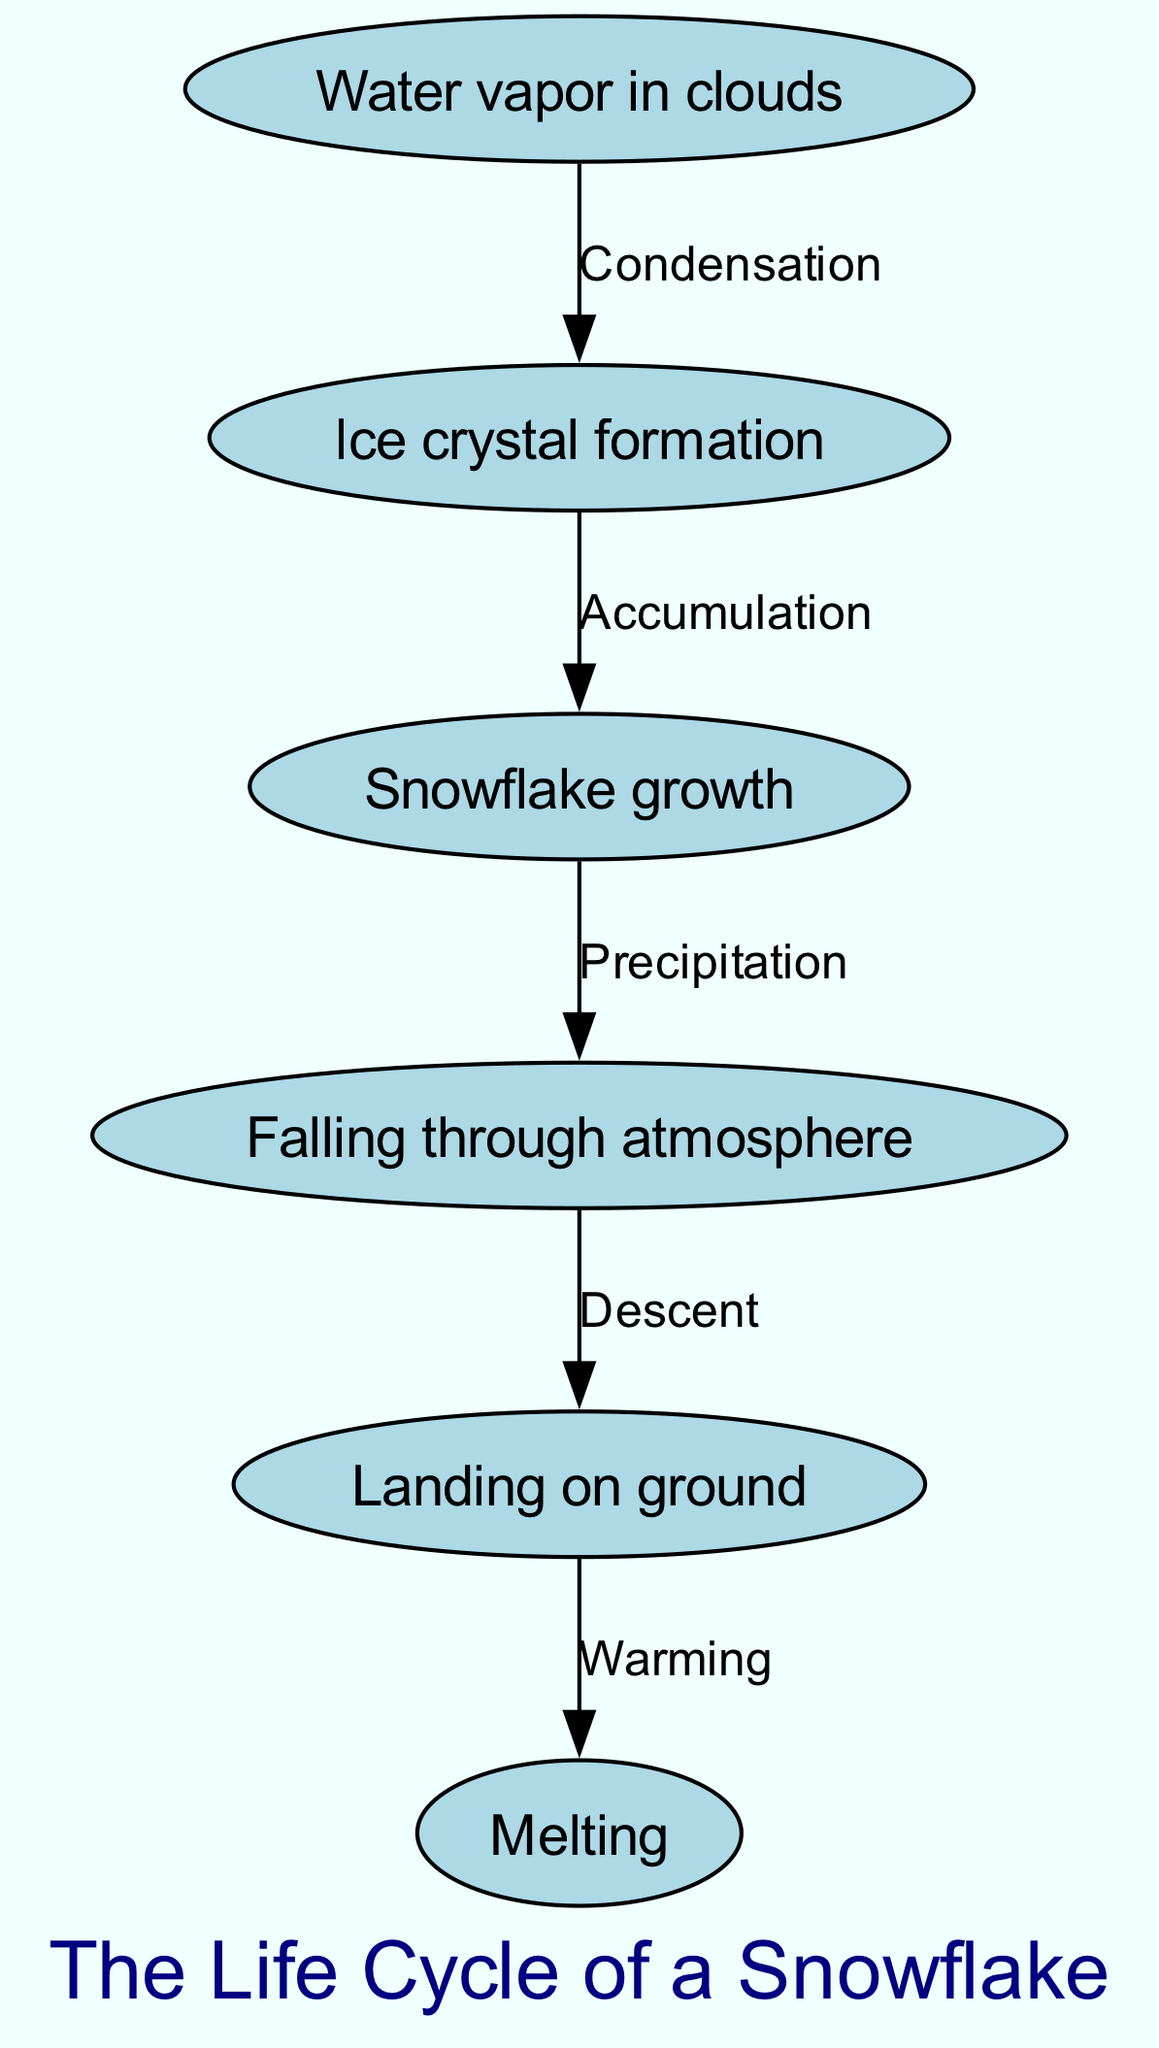What is the first step in the snowflake life cycle? The diagram shows "Water vapor in clouds" as the first node, indicating it is where the process begins.
Answer: Water vapor in clouds How many nodes are in the diagram? Counting the nodes listed, there are six distinct nodes: "Water vapor in clouds," "Ice crystal formation," "Snowflake growth," "Falling through atmosphere," "Landing on ground," and "Melting."
Answer: 6 What is the last step before melting? The diagram indicates that "Landing on ground" occurs just prior to the "Melting" node, representing the immediate step before the snowflake melts.
Answer: Landing on ground Which process leads from snowflake growth to falling through the atmosphere? The edge connecting these two nodes is labeled "Precipitation," which shows that this is the process that links them.
Answer: Precipitation What is the relationship between ice crystal formation and snowflake growth? The "Accumulation" label on the edge between these two nodes indicates the relationship, showing how ice crystals lead to the growth of snowflakes.
Answer: Accumulation How many edges are there in the diagram? By analyzing the connections between the nodes, there are five edges that connect the six nodes, indicating the processes that link each stage.
Answer: 5 What is the transition from landing on ground to melting called? The edge from "Landing on ground" to "Melting" is labeled "Warming," indicating that this is the process responsible for the snowflake's melting after it lands.
Answer: Warming What type of transformation occurs between water vapor in clouds and ice crystal formation? The edge between these two nodes is labeled "Condensation," indicating the type of transformation that occurs as water vapor changes into ice crystals.
Answer: Condensation 